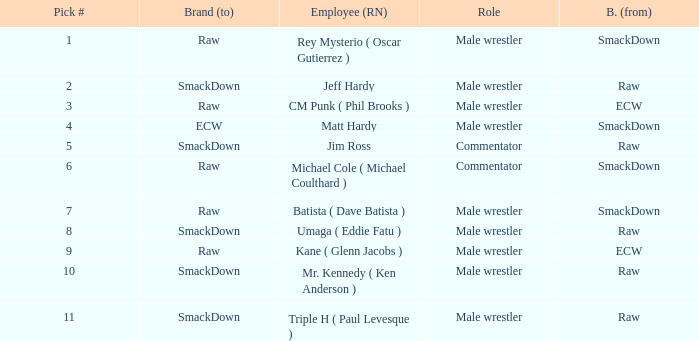Pick # 3 works for which brand? ECW. 